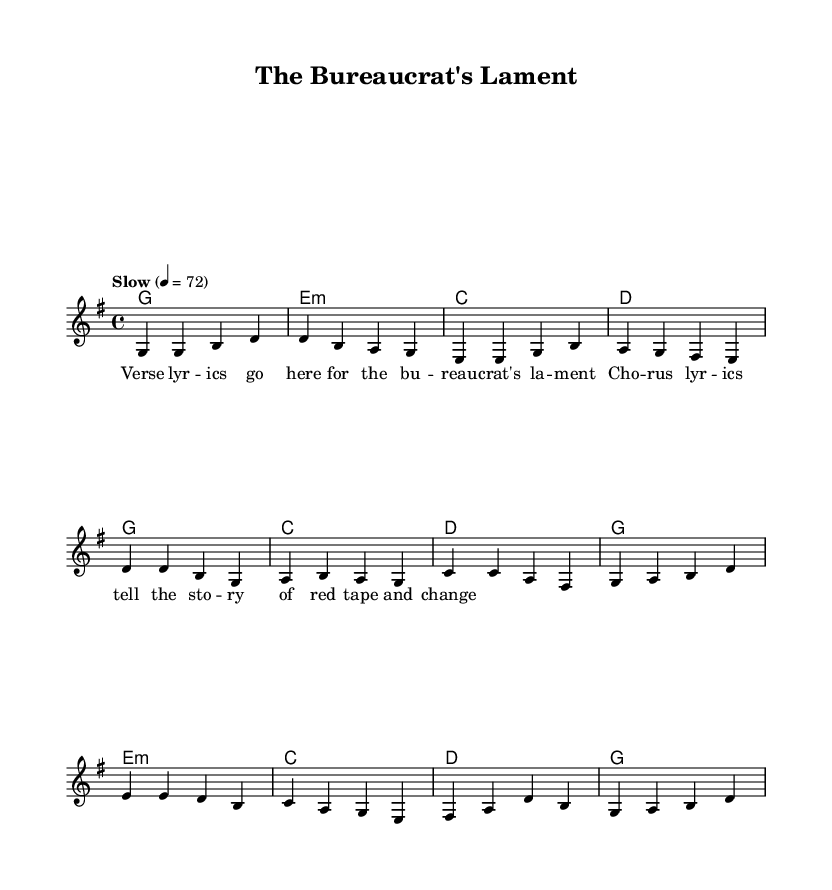What is the key signature of this music? The key signature is indicated on the staff at the beginning of the music. This score has a single sharp symbol, indicating that it is in G major, which has one sharp (F#).
Answer: G major What is the time signature of this music? The time signature is also indicated at the beginning of the music. It shows a 4 over 4, meaning there are four beats in each measure and the quarter note gets one beat.
Answer: 4/4 What is the tempo marking of this music? The tempo is specified in the score with the word "Slow" followed by a number indicating beats per minute. Here, it shows "Slow" at a tempo of 72 beats per minute.
Answer: Slow, 72 How many measures are in the verse section of the song? By counting the bars in the melody section labeled as "Verse," we find four measures that make up the verse.
Answer: 4 In which section does the lyric mention "red tape and change"? The lyrics that mention "red tape and change" belong to the chorus section, as indicated by the structure of the lyrics presented in the score.
Answer: Chorus What type of progression is used in the verse harmonies? Analyzing the chord structure found in the verse harmonies, namely the sequence of G, E minor, C, D, it shows a common movement in many country ballads. This progression is indicative of diatonic harmony typical in the genre.
Answer: Diatonic harmony What theme does "The Bureaucrat's Lament" primarily explore? The title and lyrics indicate that it explores themes related to bureaucracy, government, and the complications involved, reflecting a storytelling characteristic common in country ballads.
Answer: Government and policy themes 